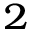Convert formula to latex. <formula><loc_0><loc_0><loc_500><loc_500>_ { 2 }</formula> 